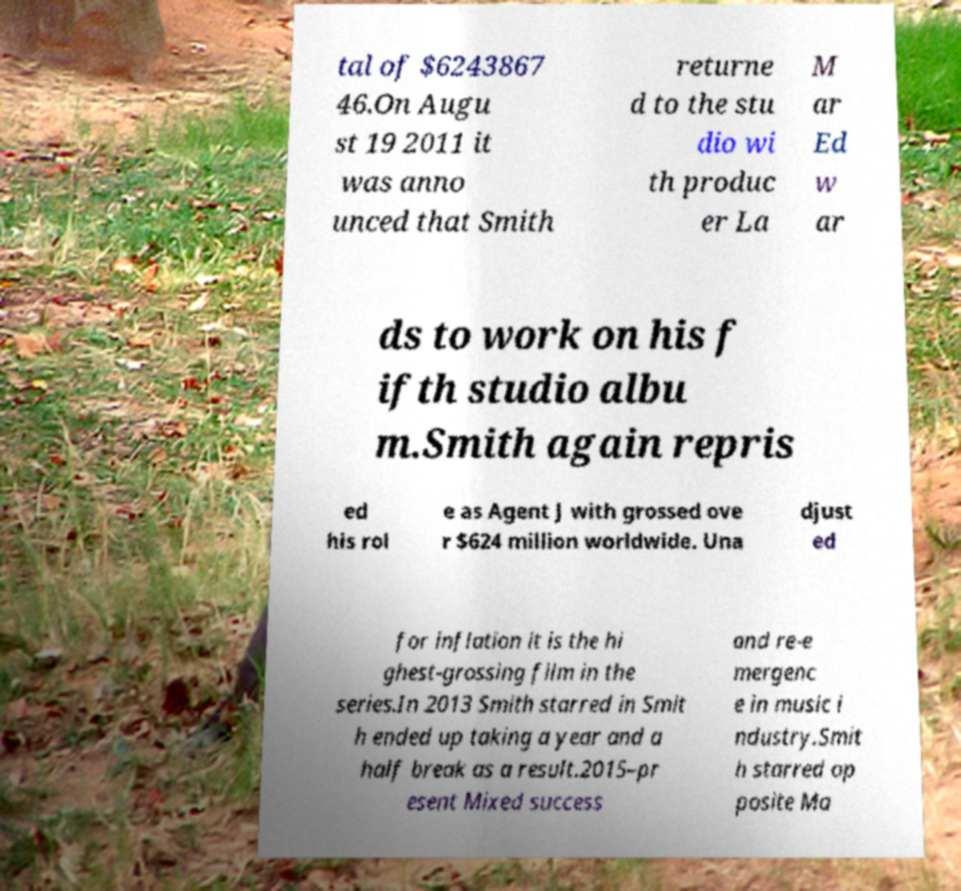Could you extract and type out the text from this image? tal of $6243867 46.On Augu st 19 2011 it was anno unced that Smith returne d to the stu dio wi th produc er La M ar Ed w ar ds to work on his f ifth studio albu m.Smith again repris ed his rol e as Agent J with grossed ove r $624 million worldwide. Una djust ed for inflation it is the hi ghest-grossing film in the series.In 2013 Smith starred in Smit h ended up taking a year and a half break as a result.2015–pr esent Mixed success and re-e mergenc e in music i ndustry.Smit h starred op posite Ma 